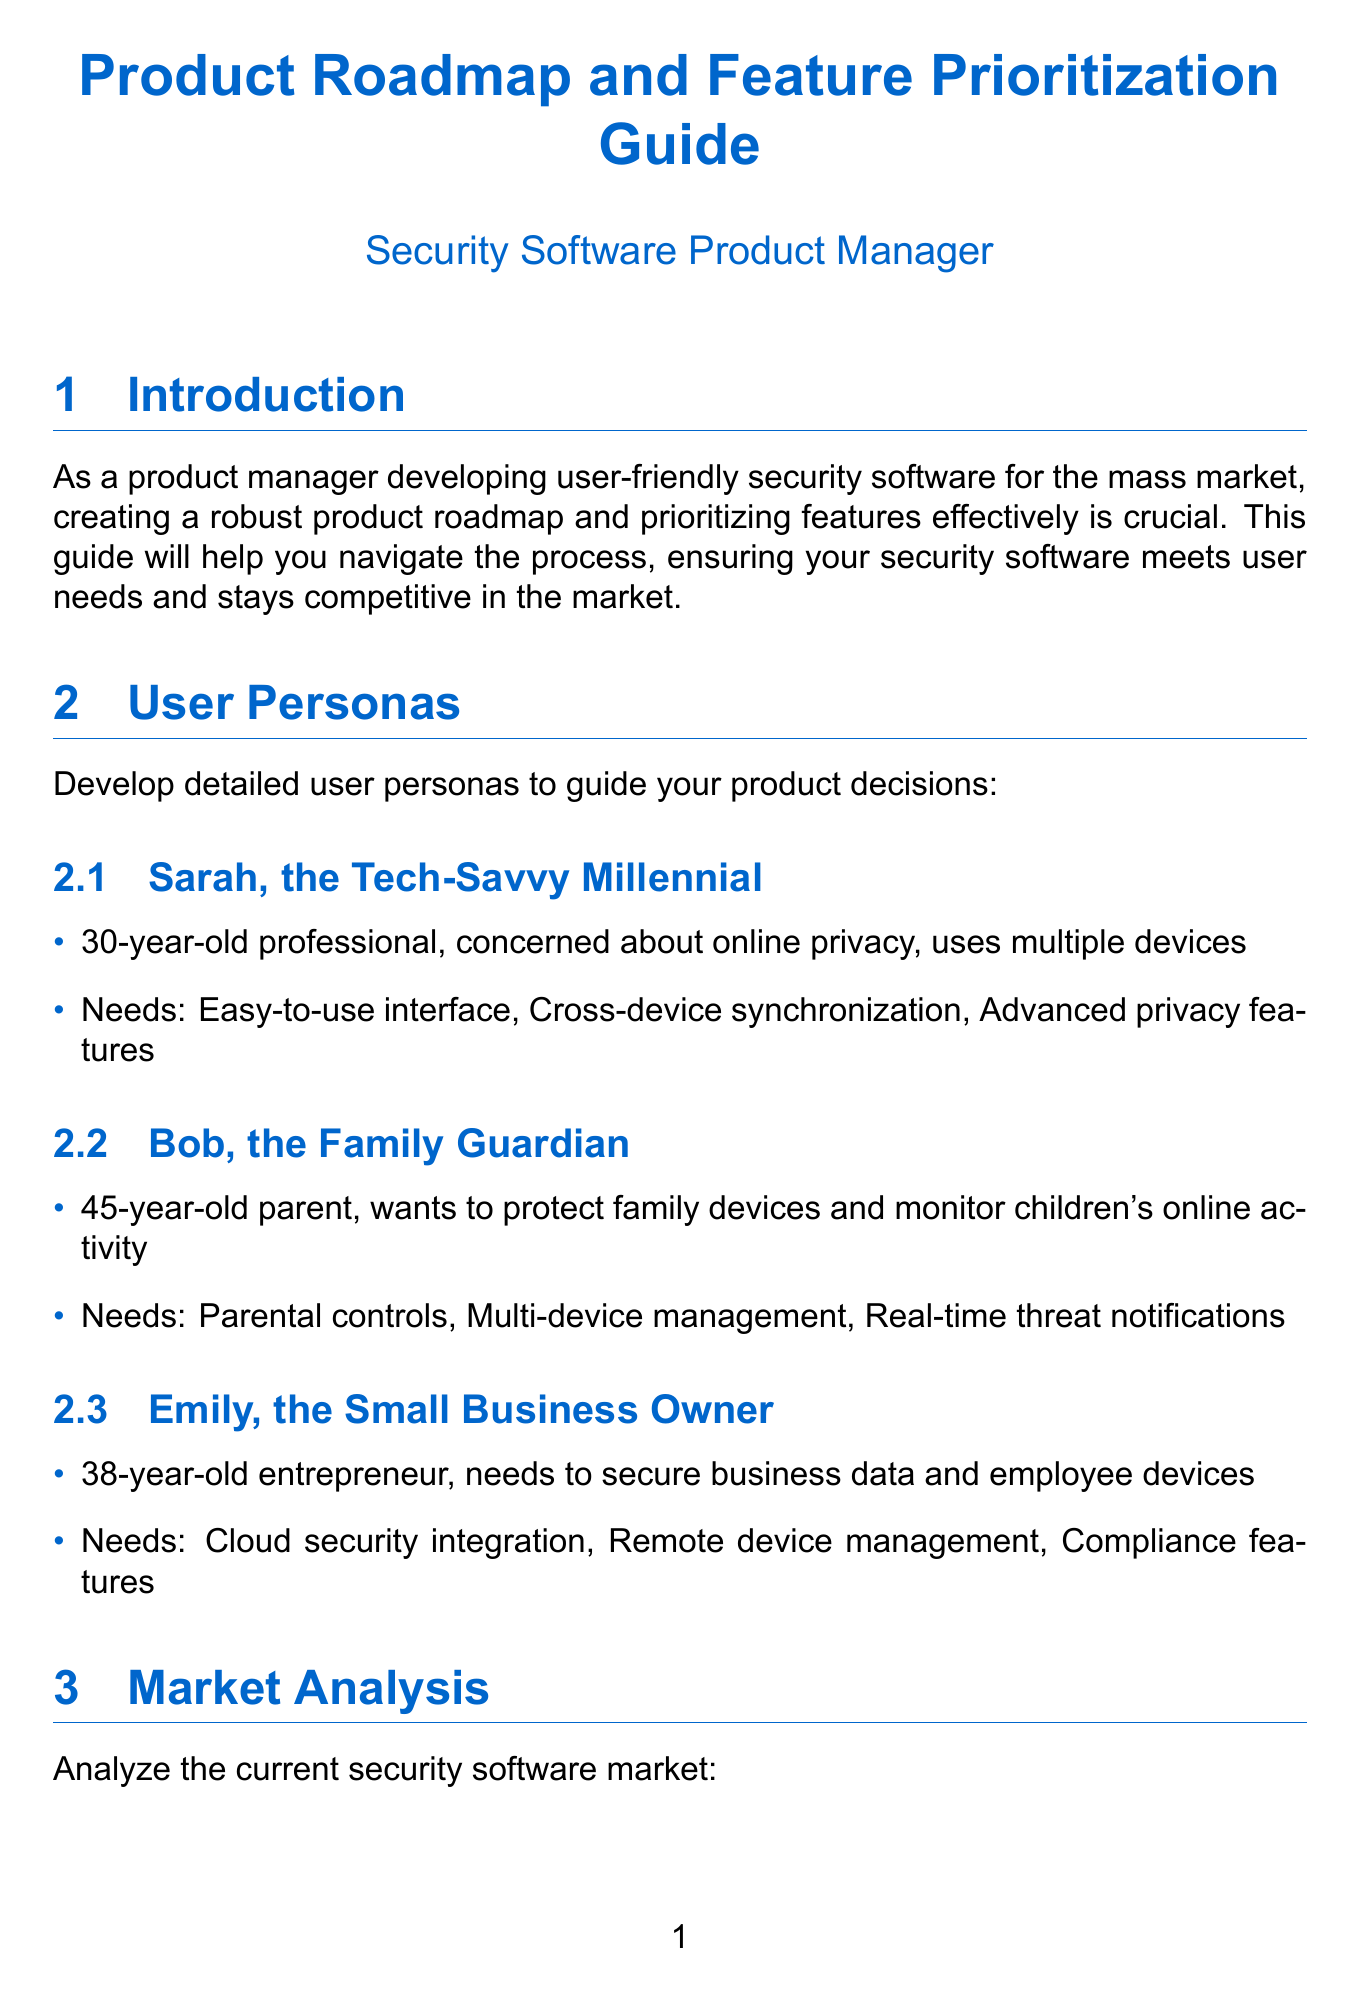What is the estimated market size of the security software sector? The document states that the current market size is $45.5 billion.
Answer: $45.5 billion What feature is being prioritized in Q4 2023? The document mentions that the theme for Q4 2023 is User Experience Optimization, which includes certain features.
Answer: User Experience Optimization Who is the user persona described as a 45-year-old parent? The document identifies Bob as the user persona that fits this description.
Answer: Bob What is one of the strengths of Norton 360? The document lists brand recognition as a strength of Norton 360.
Answer: Brand recognition Which prioritization tool involves scoring based on reach, impact, confidence, and effort? The RICE scoring method includes these criteria for prioritization.
Answer: RICE scoring What is the projected growth rate of the market over the next five years? The document specifies a projected growth rate of 12.5% CAGR over the next five years.
Answer: 12.5% CAGR What are the needs of Sarah, the Tech-Savvy Millennial? The document lists needs including easy-to-use interface, cross-device synchronization, and advanced privacy features.
Answer: Easy-to-use interface, cross-device synchronization, advanced privacy features Which feature is associated with the theme of Advanced Protection for Q1 2024? The document mentions behavior-based ransomware protection as a feature under this theme.
Answer: Behavior-based ransomware protection How often should roadmap reviews with stakeholders be performed? The document states that quarterly roadmap reviews should be conducted.
Answer: Quarterly 